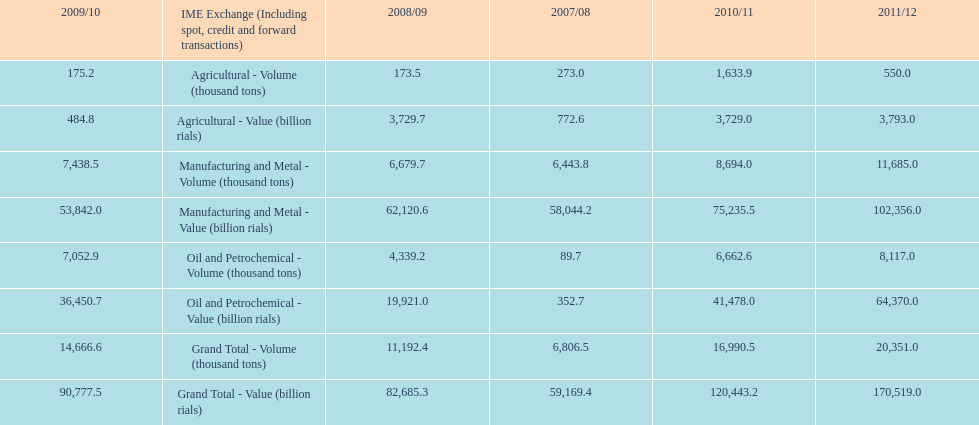How many consecutive year did the grand total value grow in iran? 4. 